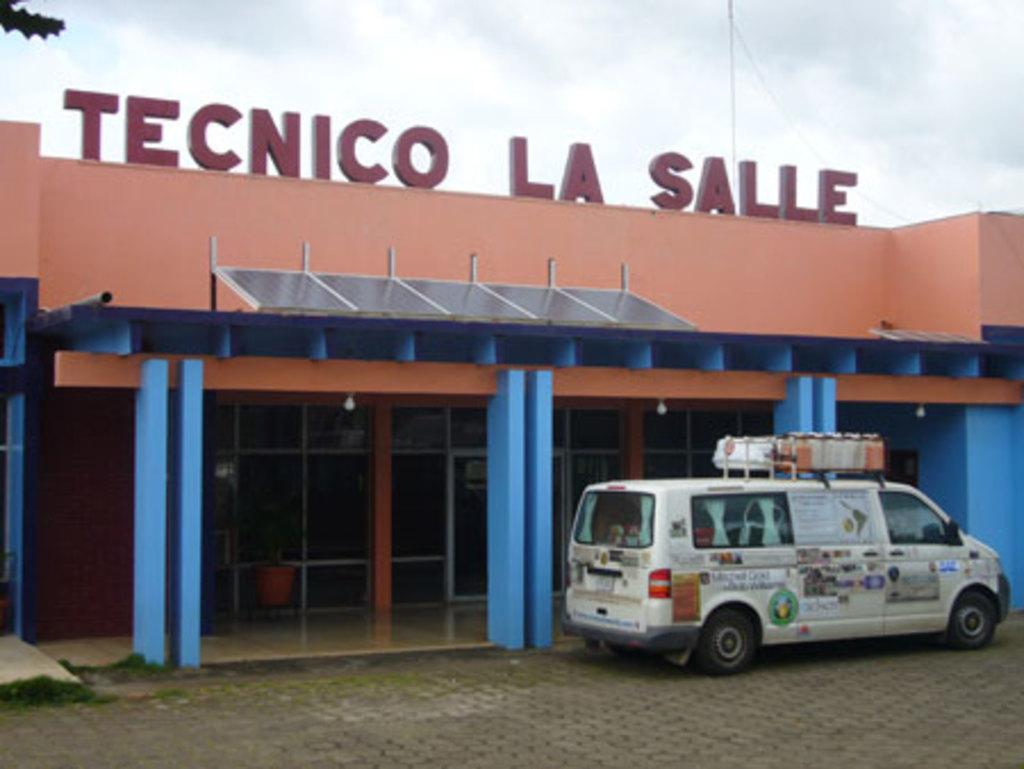What type of vehicle is in the image? There is a white van in the image. Where is the white van located in relation to the image? The white van is parked in the front. What can be seen in the background of the image? There is a brown and blue color building in the background. How many frogs are sitting on the roof of the white van in the image? There are no frogs present in the image, so it is not possible to determine how many might be sitting on the roof of the van. 